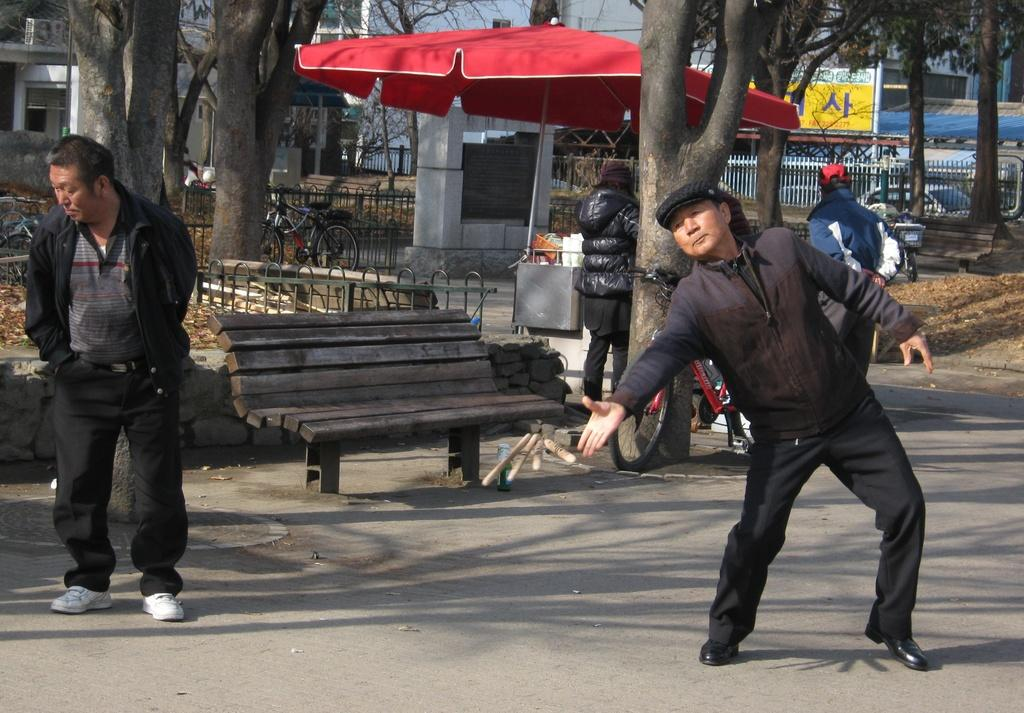How many people are present in the image? There are four persons standing on a road in the image. What can be seen in the background of the image? There is a tent, a bench, trees, the sky, and buildings in the background. What might the people be doing in the image? It is not clear from the image what the people are doing, but they are standing on a road. What type of lettuce is being used as a club by one of the persons in the image? There is no lettuce or club present in the image; it only features four persons standing on a road and various background elements. 